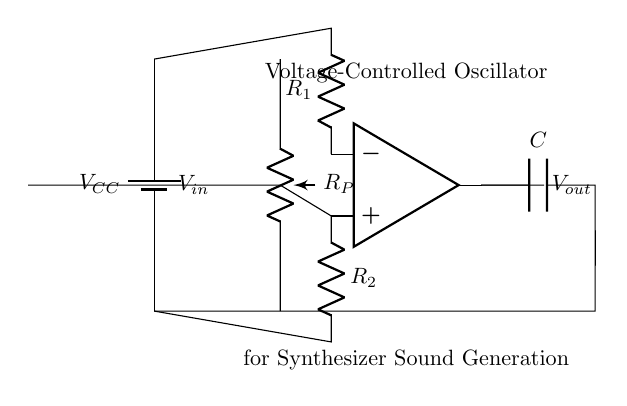What is the power supply voltage in this circuit? The power supply is labeled as VCC in the circuit diagram, which typically represents the positive voltage supplied to the circuit.
Answer: VCC What type of component is used to create the oscillation? The circuit diagram includes an operational amplifier, which is essential for generating oscillations in this voltage-controlled oscillator.
Answer: Operational amplifier How many resistors are present in the circuit? The diagram shows two resistors labeled R1 and R2, indicating that there are two resistors in total within the circuit configuration.
Answer: 2 What is the role of the capacitor in this circuit? The capacitor is connected in the feedback loop of the op-amp, which contributes to the timing characteristics necessary for the oscillation frequency of the voltage-controlled oscillator.
Answer: Timing Which component can adjust the frequency of oscillation? The potentiometer, labeled RP in the circuit, allows for variable resistance, thereby enabling control over the frequency of the oscillation produced in the circuit.
Answer: Potentiometer How is the input voltage represented in this diagram? The input voltage is denoted as Vin, which shows how it is connected to the positive input of the operational amplifier, affecting the output oscillation.
Answer: Vin What does Vout signify in this context? The output voltage Vout represents the amplified signal generated by the oscillator circuit based on the input voltage and configuration of the components, particularly influenced by the op-amp.
Answer: Vout 